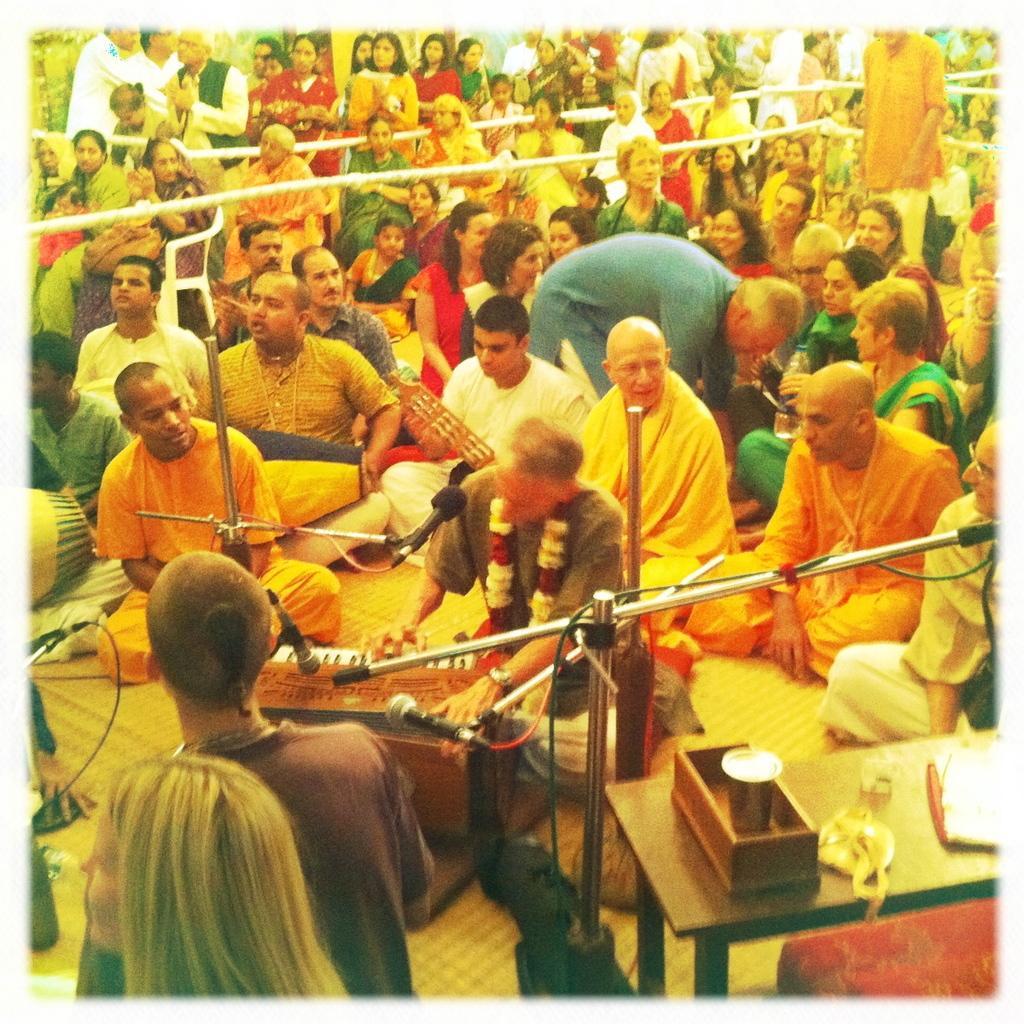Can you describe this image briefly? In this picture we can see people, ropes, microphones, stands and objects. We can see few people are sitting and few are standing. On the right side of the picture we can see glass and few objects on a table. We can see a person playing a musical instrument. 